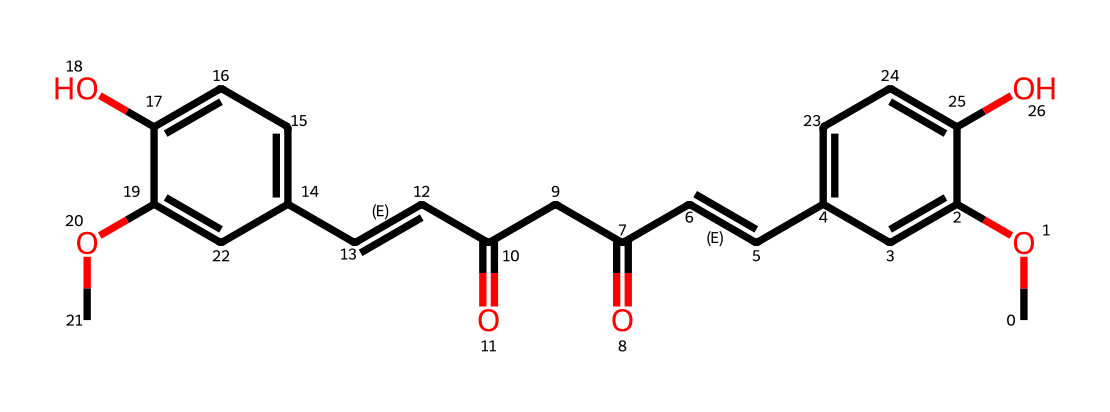how many carbon atoms are in the structure? The SMILES representation can be analyzed to count the number of carbon atoms denoted by the letter "C". By examining the entire structure, we identify that there are 21 carbon atoms present.
Answer: 21 what functional groups are present in curcumin? The SMILES notation reveals several functional groups. We see hydroxyl (-OH) groups represented in the structure, as well as methoxy (-OCH3) groups. Specifically, there are two hydroxyl groups and two methoxy groups.
Answer: hydroxyl and methoxy what is the molecular formula of curcumin? To deduce the molecular formula, we summarize the counts of each type of atom from the structure. From the analysis, we find that the molecular formula is C21H20O6, which corresponds to 21 carbon atoms, 20 hydrogen atoms, and 6 oxygen atoms.
Answer: C21H20O6 how many double bonds are in the structure? By examining the SMILES code, we notice that double bonds are represented by the "=" character. In this structure, we identify a total of 4 double bonds connecting various carbon atoms.
Answer: 4 what role does curcumin play as an antioxidant? Curcumin possesses multiple phenolic groups which facilitate electron donation, thus allowing it to neutralize free radicals. This ability to donate electrons aids in its role as an antioxidant in biological systems.
Answer: electron donor how does the presence of multiple hydroxyl groups affect the solubility of curcumin? Multiple hydroxyl groups enhance the solubility of curcumin in polar solvents, such as water, because of hydrogen bonding interactions. The presence of these groups increases hydrophilicity, allowing for better solubility.
Answer: increases solubility what makes curcumin a biologically active compound? Curcumin's complex structure with multiple functional groups, especially the phenolic and methoxy units, contributes to its biological activities like anti-inflammatory and antioxidant effects, making it biologically active.
Answer: biologically active 